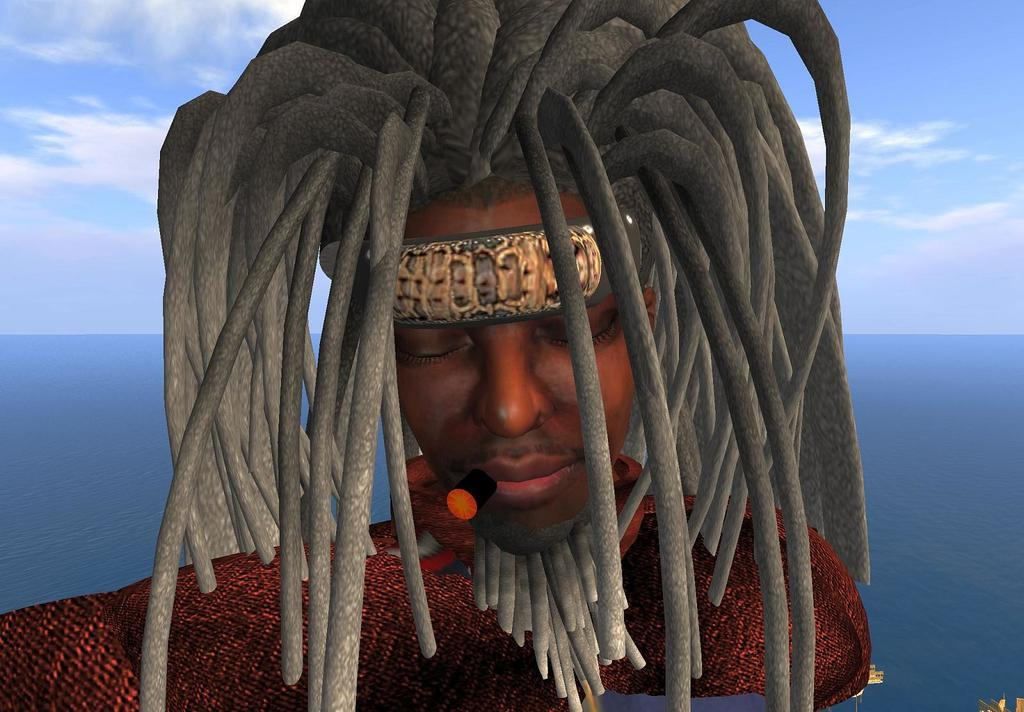What type of image is being described? The image is animated. Can you describe the character in the image? There is a man in the image. What is the man holding in his mouth? The man has a cigar in his mouth. What can be observed about the man's hair? The man has long hair on his head. What type of milk does the man drink from his throne in the image? There is no throne or milk present in the image; it features an animated man with a cigar in his mouth and long hair. 